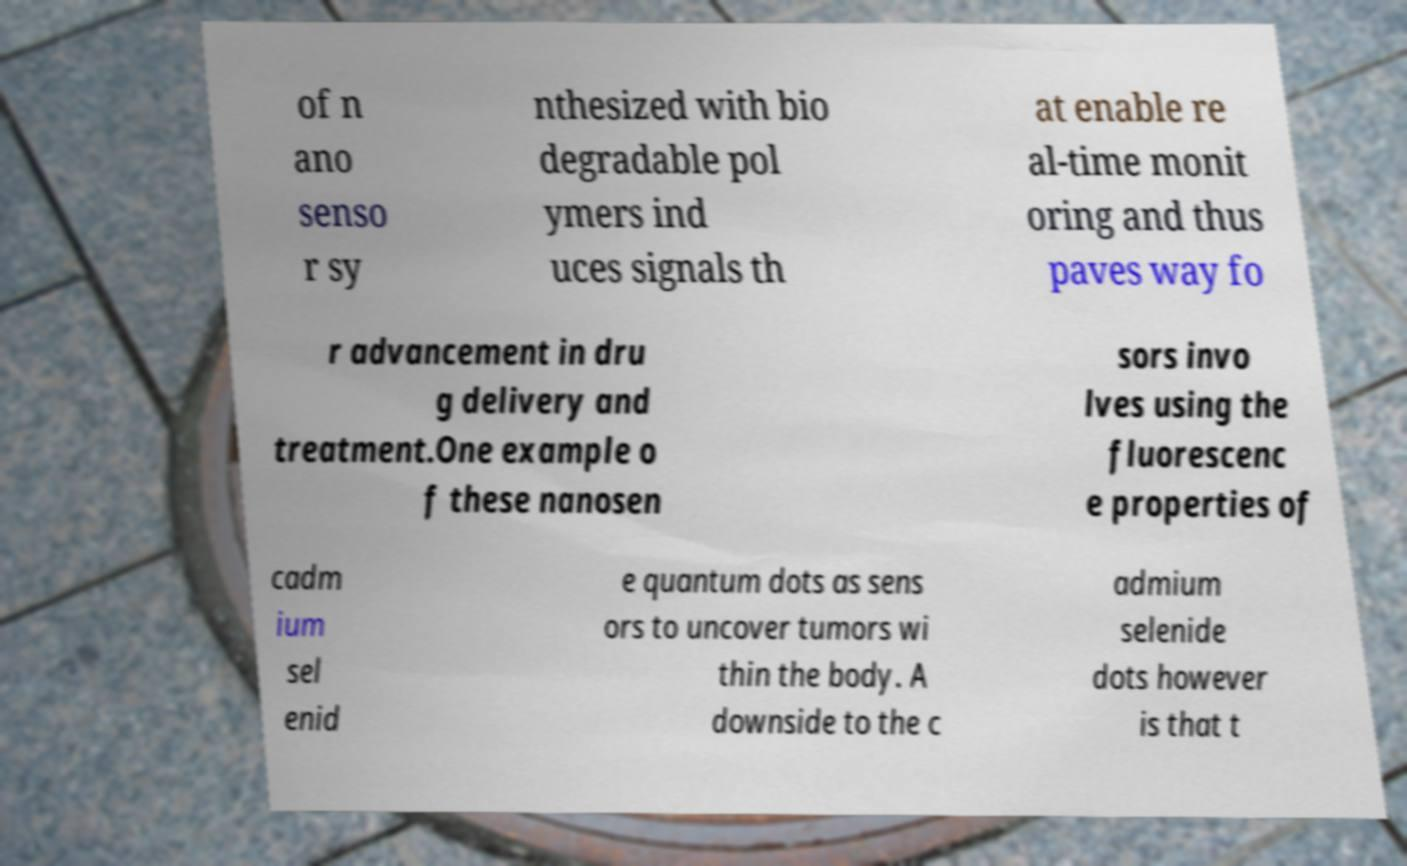What messages or text are displayed in this image? I need them in a readable, typed format. of n ano senso r sy nthesized with bio degradable pol ymers ind uces signals th at enable re al-time monit oring and thus paves way fo r advancement in dru g delivery and treatment.One example o f these nanosen sors invo lves using the fluorescenc e properties of cadm ium sel enid e quantum dots as sens ors to uncover tumors wi thin the body. A downside to the c admium selenide dots however is that t 